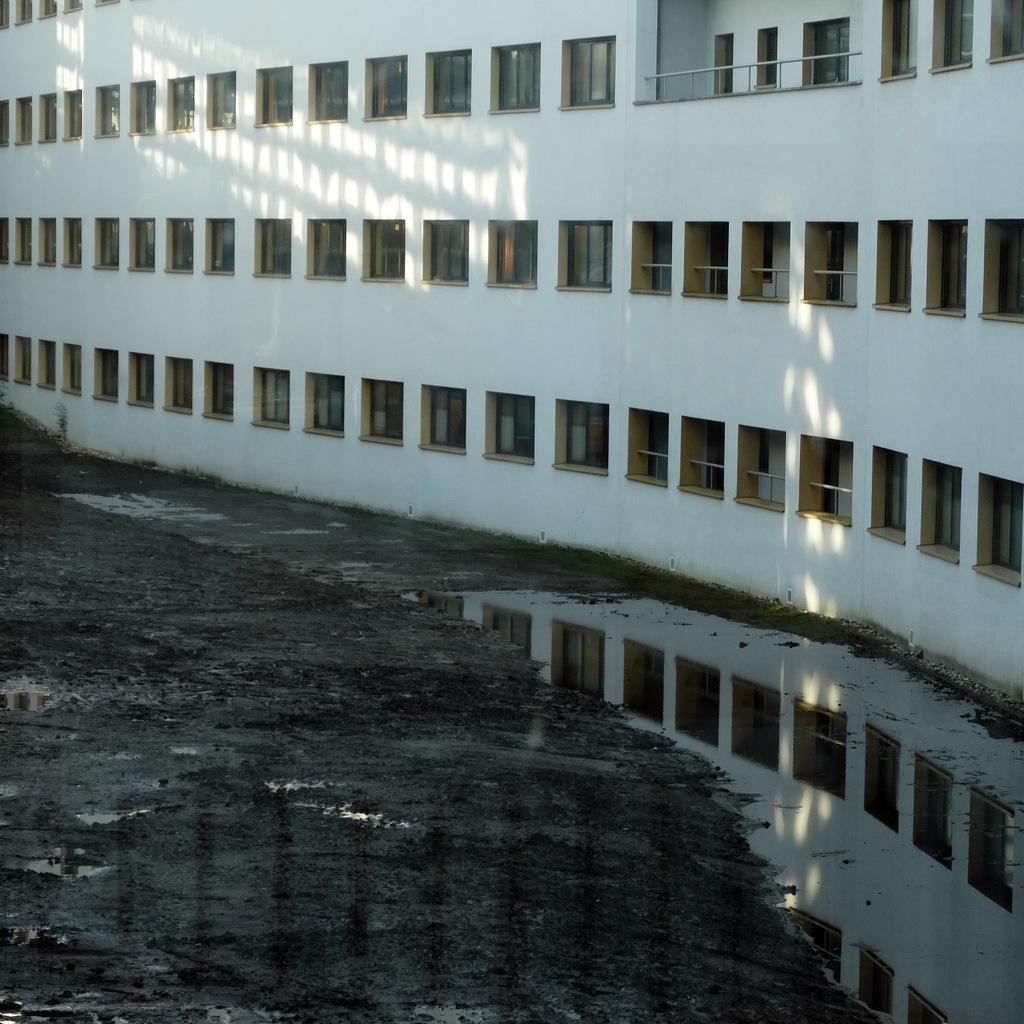What type of structure is present in the image? There is a building in the image. What feature can be seen on the building? The building has windows. What is the condition of the ground in the image? There is water and mud visible on the ground. Where is the uncle's store located in the image? There is no uncle or store mentioned or visible in the image. 